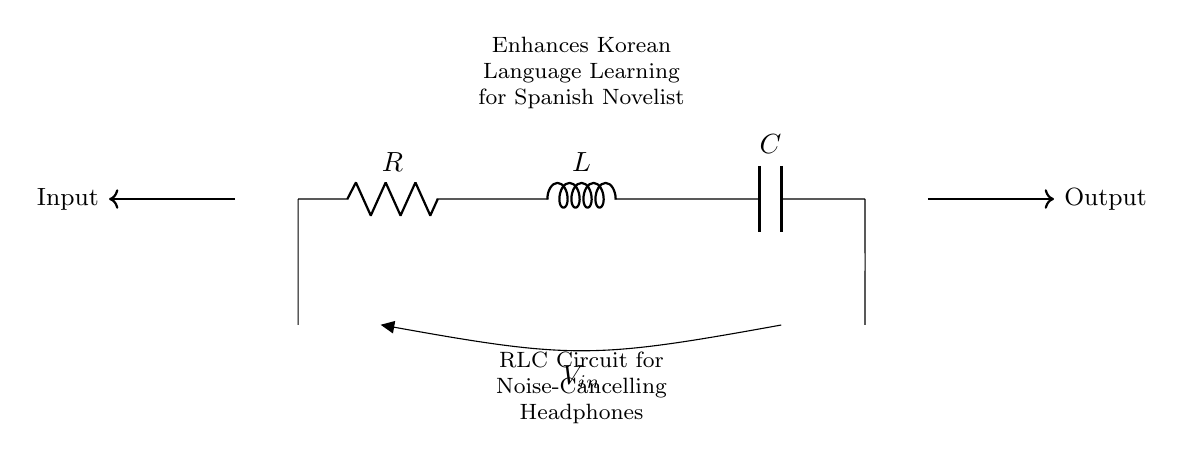What components are present in this circuit? The circuit contains a resistor, an inductor, and a capacitor, typically represented by R, L, and C. These are basic passive components used in electronic circuits.
Answer: Resistor, Inductor, Capacitor What is the purpose of this RLC circuit? The purpose of this RLC circuit is to enhance audio quality by filtering out noise, which is particularly beneficial for language learning by making the audio clearer.
Answer: Noise-cancelling What is the input to this circuit? The input is a voltage signal represented as V_in, which is fed into the circuit to process the audio.
Answer: V_in Which component is responsible for the energy storage in the circuit? The capacitor is responsible for energy storage in the circuit by accumulating charge and thus affecting the filter characteristics.
Answer: Capacitor How does the inductor affect the circuit? The inductor resists changes in current and thus can help to filter high-frequency noise, playing a crucial role in the audio processing within the circuit.
Answer: Filters high-frequency noise Why is the RLC configuration chosen for noise cancelling in headphones? The RLC configuration enables selective frequency response, allowing specific sound frequencies to be enhanced or suppressed, making it ideal for improving language learning experiences by reducing background noise.
Answer: Selective frequency response 